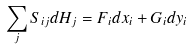<formula> <loc_0><loc_0><loc_500><loc_500>\sum _ { j } S _ { i j } d H _ { j } = F _ { i } d x _ { i } + G _ { i } d y _ { i }</formula> 